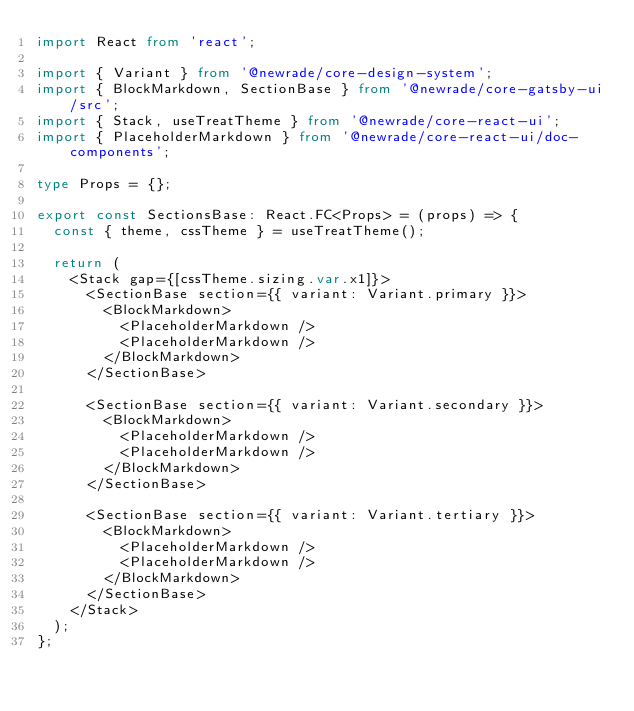<code> <loc_0><loc_0><loc_500><loc_500><_TypeScript_>import React from 'react';

import { Variant } from '@newrade/core-design-system';
import { BlockMarkdown, SectionBase } from '@newrade/core-gatsby-ui/src';
import { Stack, useTreatTheme } from '@newrade/core-react-ui';
import { PlaceholderMarkdown } from '@newrade/core-react-ui/doc-components';

type Props = {};

export const SectionsBase: React.FC<Props> = (props) => {
  const { theme, cssTheme } = useTreatTheme();

  return (
    <Stack gap={[cssTheme.sizing.var.x1]}>
      <SectionBase section={{ variant: Variant.primary }}>
        <BlockMarkdown>
          <PlaceholderMarkdown />
          <PlaceholderMarkdown />
        </BlockMarkdown>
      </SectionBase>

      <SectionBase section={{ variant: Variant.secondary }}>
        <BlockMarkdown>
          <PlaceholderMarkdown />
          <PlaceholderMarkdown />
        </BlockMarkdown>
      </SectionBase>

      <SectionBase section={{ variant: Variant.tertiary }}>
        <BlockMarkdown>
          <PlaceholderMarkdown />
          <PlaceholderMarkdown />
        </BlockMarkdown>
      </SectionBase>
    </Stack>
  );
};
</code> 